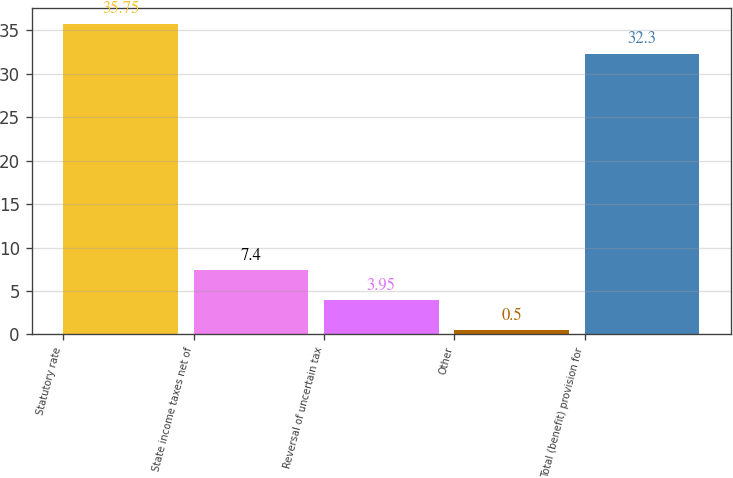Convert chart. <chart><loc_0><loc_0><loc_500><loc_500><bar_chart><fcel>Statutory rate<fcel>State income taxes net of<fcel>Reversal of uncertain tax<fcel>Other<fcel>Total (benefit) provision for<nl><fcel>35.75<fcel>7.4<fcel>3.95<fcel>0.5<fcel>32.3<nl></chart> 